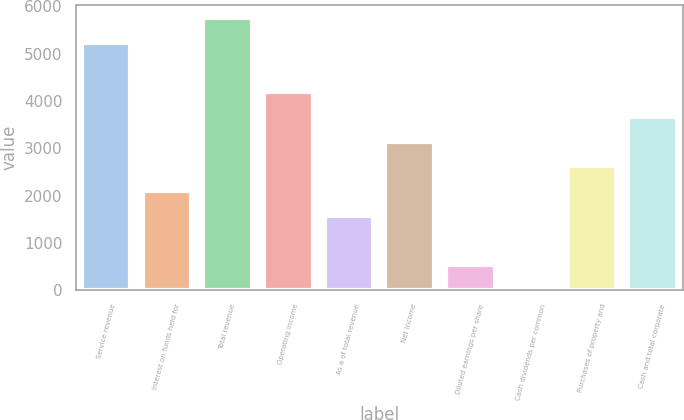Convert chart to OTSL. <chart><loc_0><loc_0><loc_500><loc_500><bar_chart><fcel>Service revenue<fcel>Interest on funds held for<fcel>Total revenue<fcel>Operating income<fcel>As a of total revenue<fcel>Net income<fcel>Diluted earnings per share<fcel>Cash dividends per common<fcel>Purchases of property and<fcel>Cash and total corporate<nl><fcel>5226.34<fcel>2091.28<fcel>5748.85<fcel>4181.32<fcel>1568.77<fcel>3136.3<fcel>523.75<fcel>1.24<fcel>2613.79<fcel>3658.81<nl></chart> 